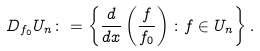<formula> <loc_0><loc_0><loc_500><loc_500>D _ { f _ { 0 } } U _ { n } \colon = \left \{ \frac { d } { d x } \left ( \frac { f } { f _ { 0 } } \right ) \colon f \in U _ { n } \right \} .</formula> 